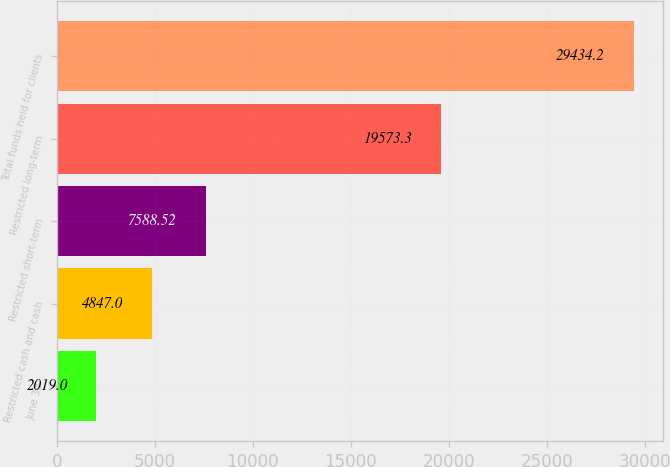<chart> <loc_0><loc_0><loc_500><loc_500><bar_chart><fcel>June 30<fcel>Restricted cash and cash<fcel>Restricted short-term<fcel>Restricted long-term<fcel>Total funds held for clients<nl><fcel>2019<fcel>4847<fcel>7588.52<fcel>19573.3<fcel>29434.2<nl></chart> 